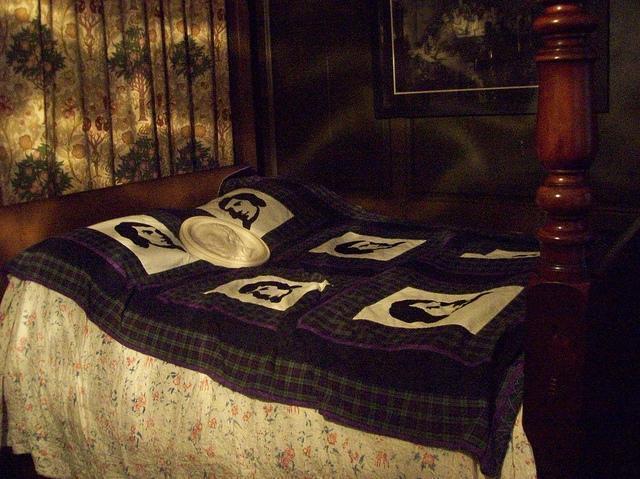What is on the bed?
Choose the correct response and explain in the format: 'Answer: answer
Rationale: rationale.'
Options: Faces, green beans, rose petals, apples. Answer: faces.
Rationale: Faces are on the blanket. 